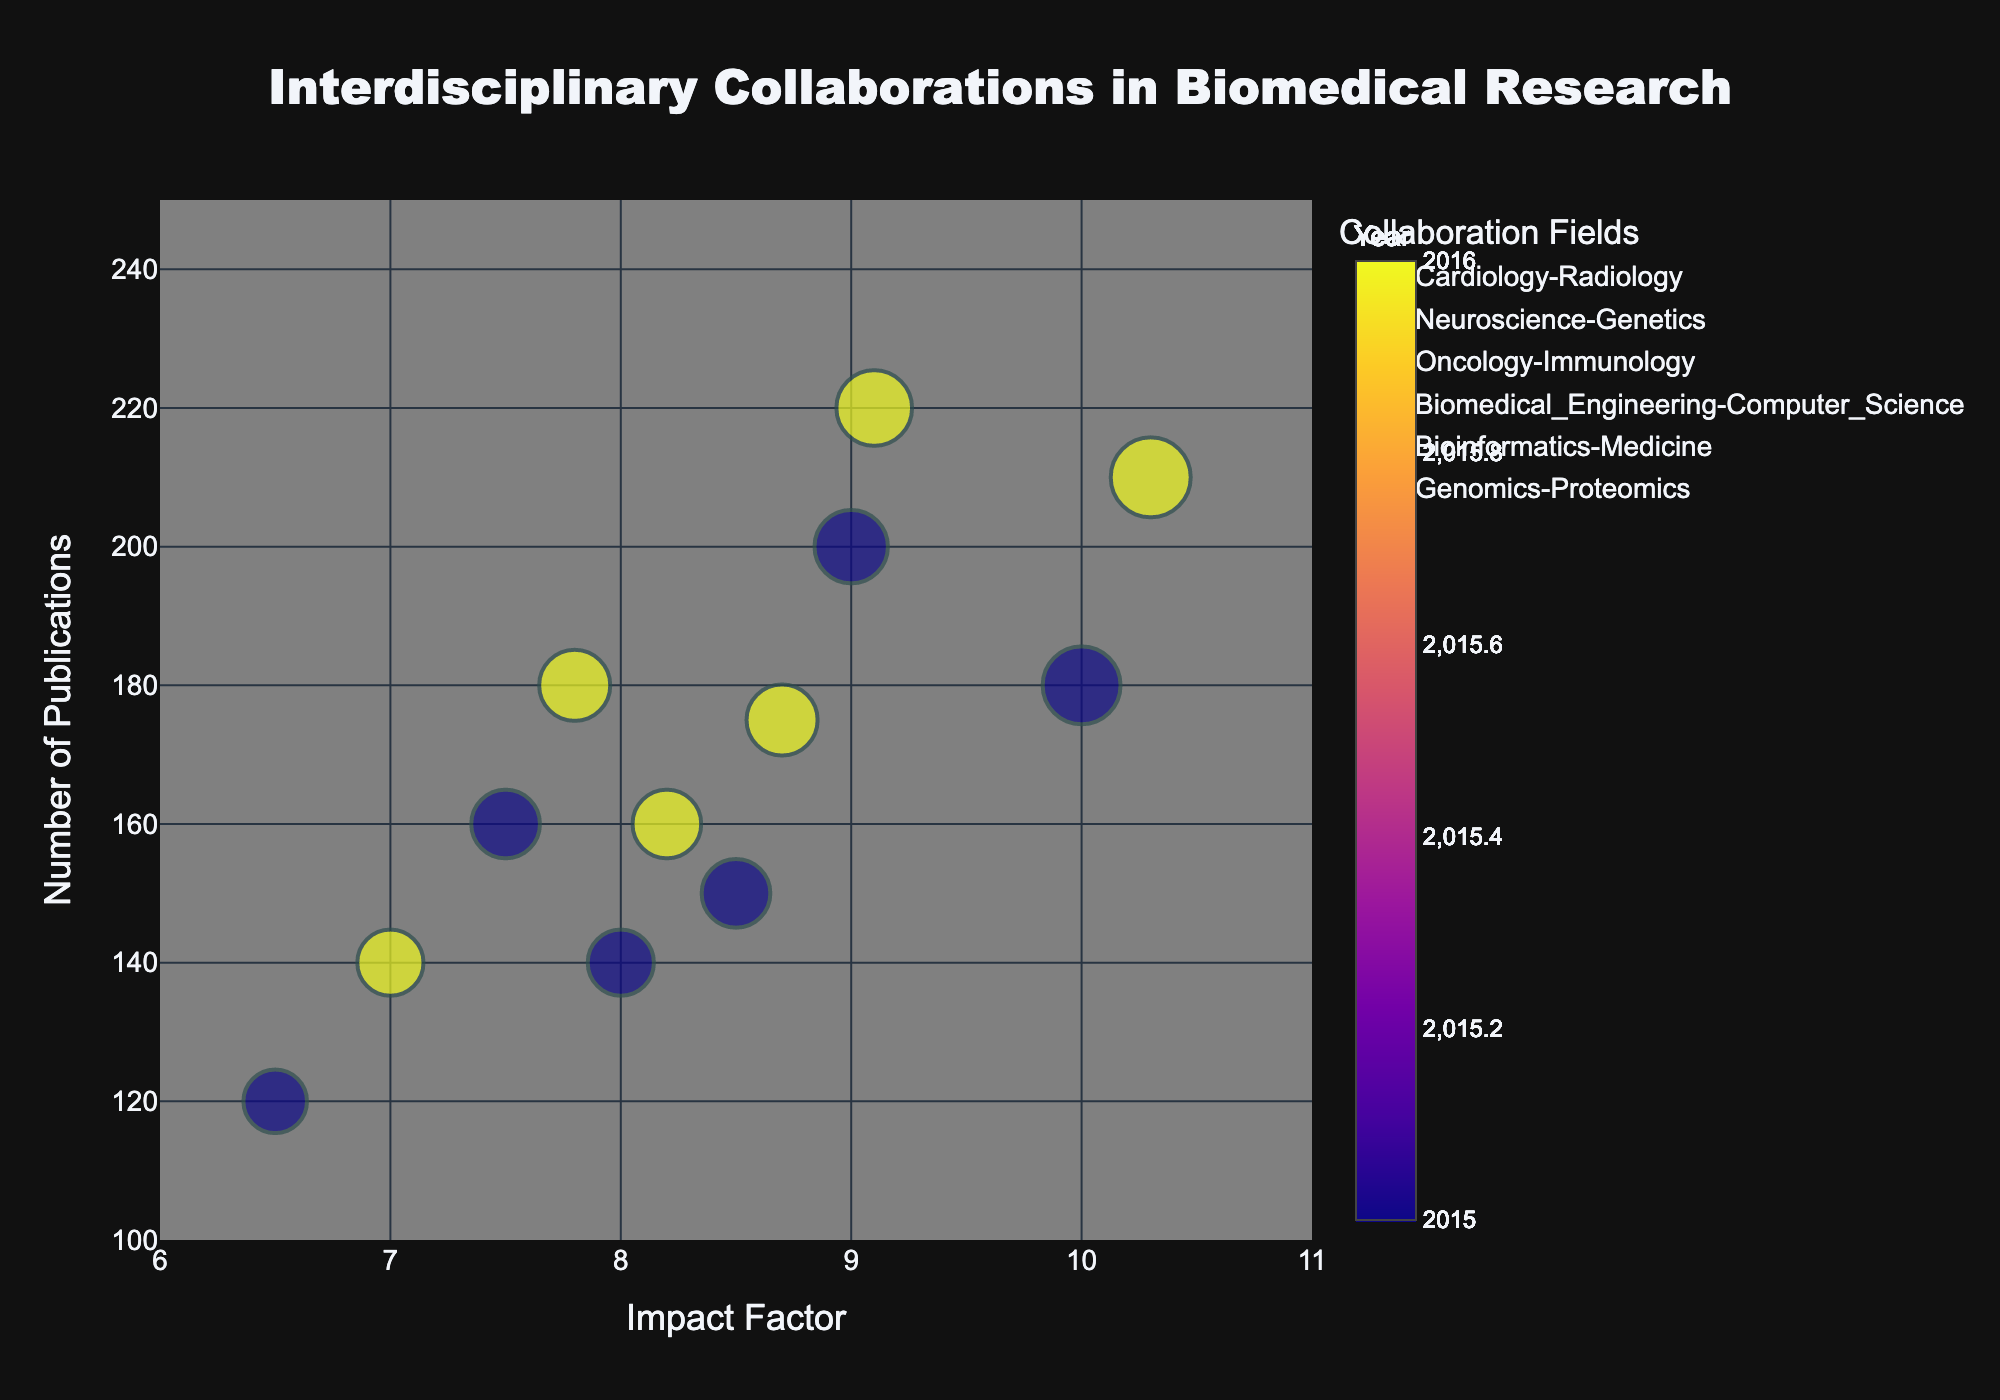What is the title of the figure? The title of the figure is prominently displayed at the top. It reads, "Interdisciplinary Collaborations in Biomedical Research".
Answer: Interdisciplinary Collaborations in Biomedical Research Which collaboration field has the highest number of publications in 2016? Observing the y-axis, "Number of Publications", and the legend, "Neuroscience-Genetics" has the highest number of publications in 2016 with a value of 220.
Answer: Neuroscience-Genetics What is the range of the x-axis? Looking at the x-axis labeled "Impact Factor", the range spans from 6 to 11.
Answer: 6 to 11 How does the collaboration intensity affect the bubble size? The bubble size is proportional to the collaboration intensity, with larger bubbles indicating higher collaboration intensity. For example, Oncology-Immunology has the largest bubbles indicating the highest intensity.
Answer: Proportional Which data point has the highest impact factor? By examining the x-axis (Impact Factor), Oncology-Immunology in 2016 has the highest impact factor at 10.3.
Answer: Oncology-Immunology in 2016 Between which two years are the comparison made? The color bar indicates that the comparisons are made between the years 2015 and 2016, with colors differentiating the years.
Answer: 2015 and 2016 What’s the average number of publications for Bioinformatics-Medicine across 2015 and 2016? For Bioinformatics-Medicine, the data points for 2015 and 2016 show 160 and 180 publications respectively. The average is (160 + 180) / 2 = 170.
Answer: 170 Which field shows the greatest increase in publications from 2015 to 2016? Comparing the y-values for each field between 2015 and 2016, Oncology-Immunology increases from 180 to 210, an increase of 30, which is the highest.
Answer: Oncology-Immunology Which collaboration fields have a collaboration intensity of 0.7 in 2015? Observing the size of bubbles for the year 2015 and comparing collaboration intensities in the legend, both Cardiology-Radiology and Bioinformatics-Medicine have a collaboration intensity of 0.7.
Answer: Cardiology-Radiology, Bioinformatics-Medicine How does the number of publications generally relate to the impact factor in 2016? Looking at bubbles positioned in 2016, it is generally seen that as the impact factor increases, the number of publications also tends to increase, showing a positive correlation.
Answer: Positive correlation 